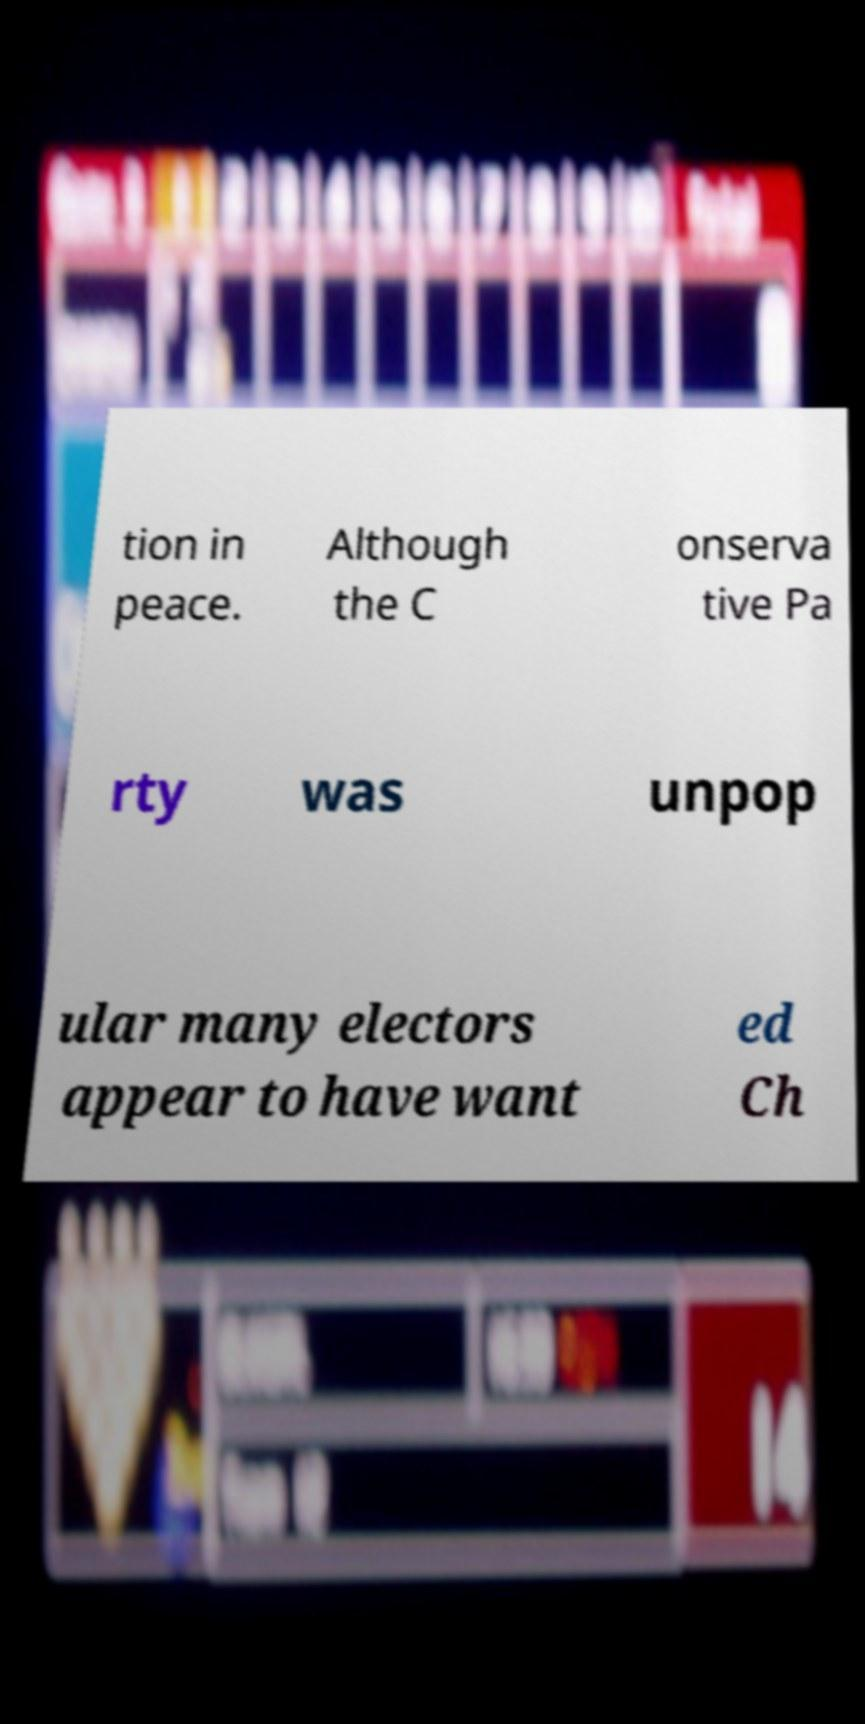Can you accurately transcribe the text from the provided image for me? tion in peace. Although the C onserva tive Pa rty was unpop ular many electors appear to have want ed Ch 